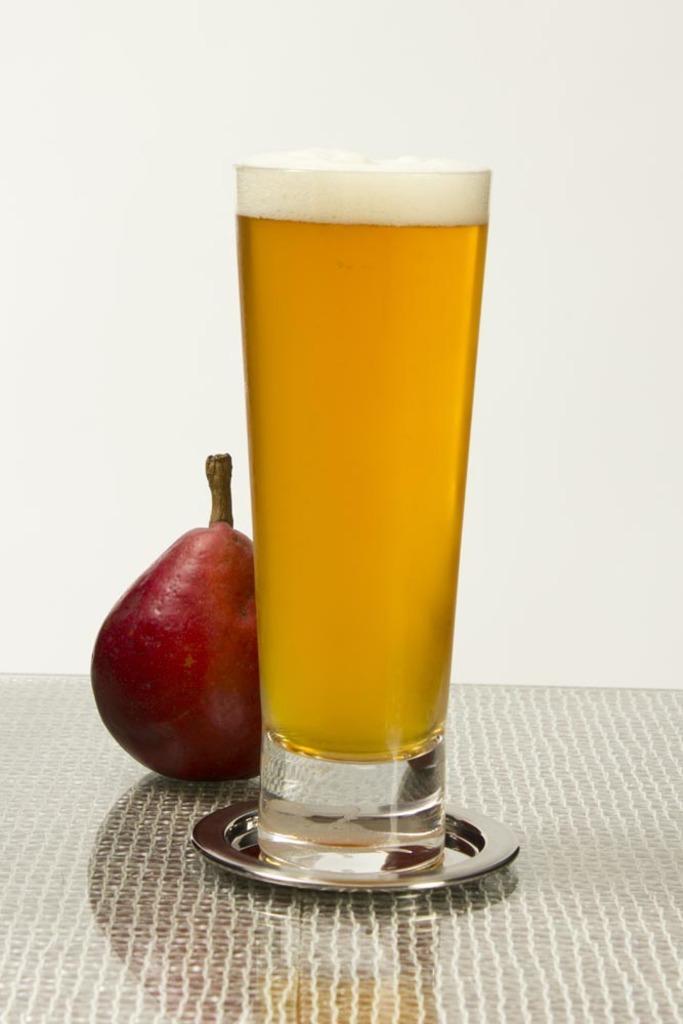Please provide a concise description of this image. In this image we can see a fruit and a glass with liquid on the table, in the background, we can see the wall. 